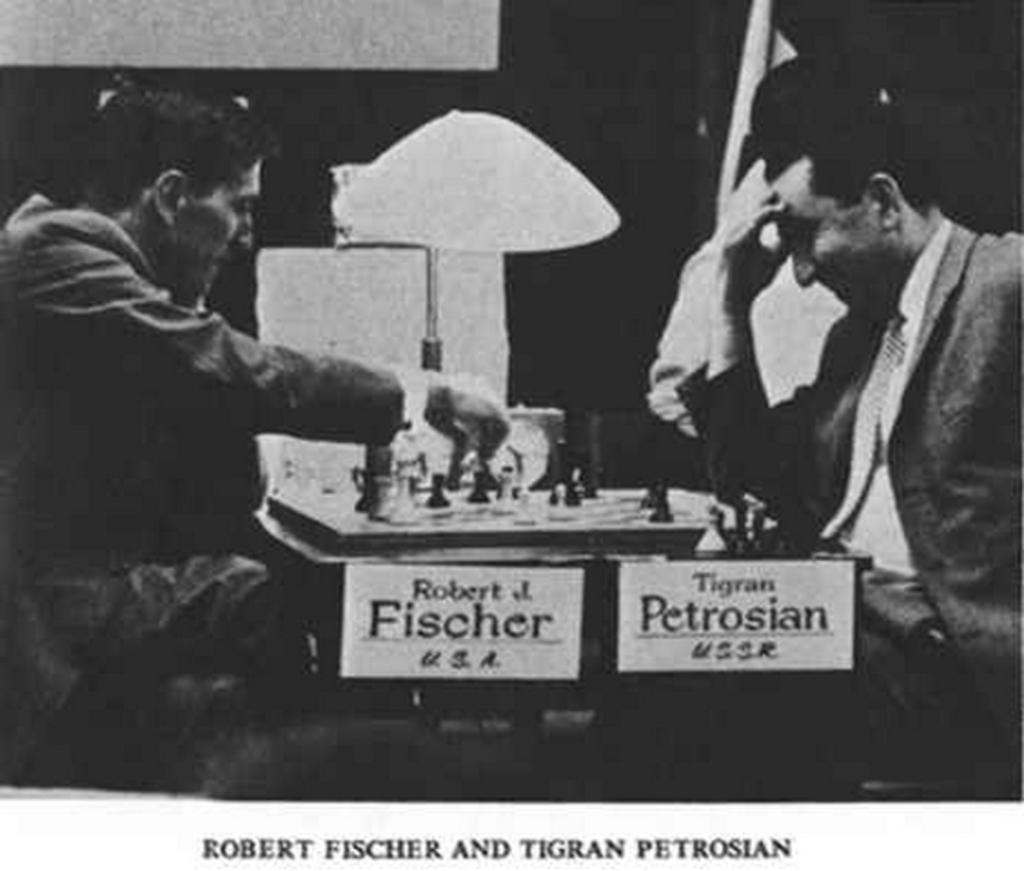Please provide a concise description of this image. In this picture we can see two people are sitting on the chairs and playing chess, which is place on the table. 